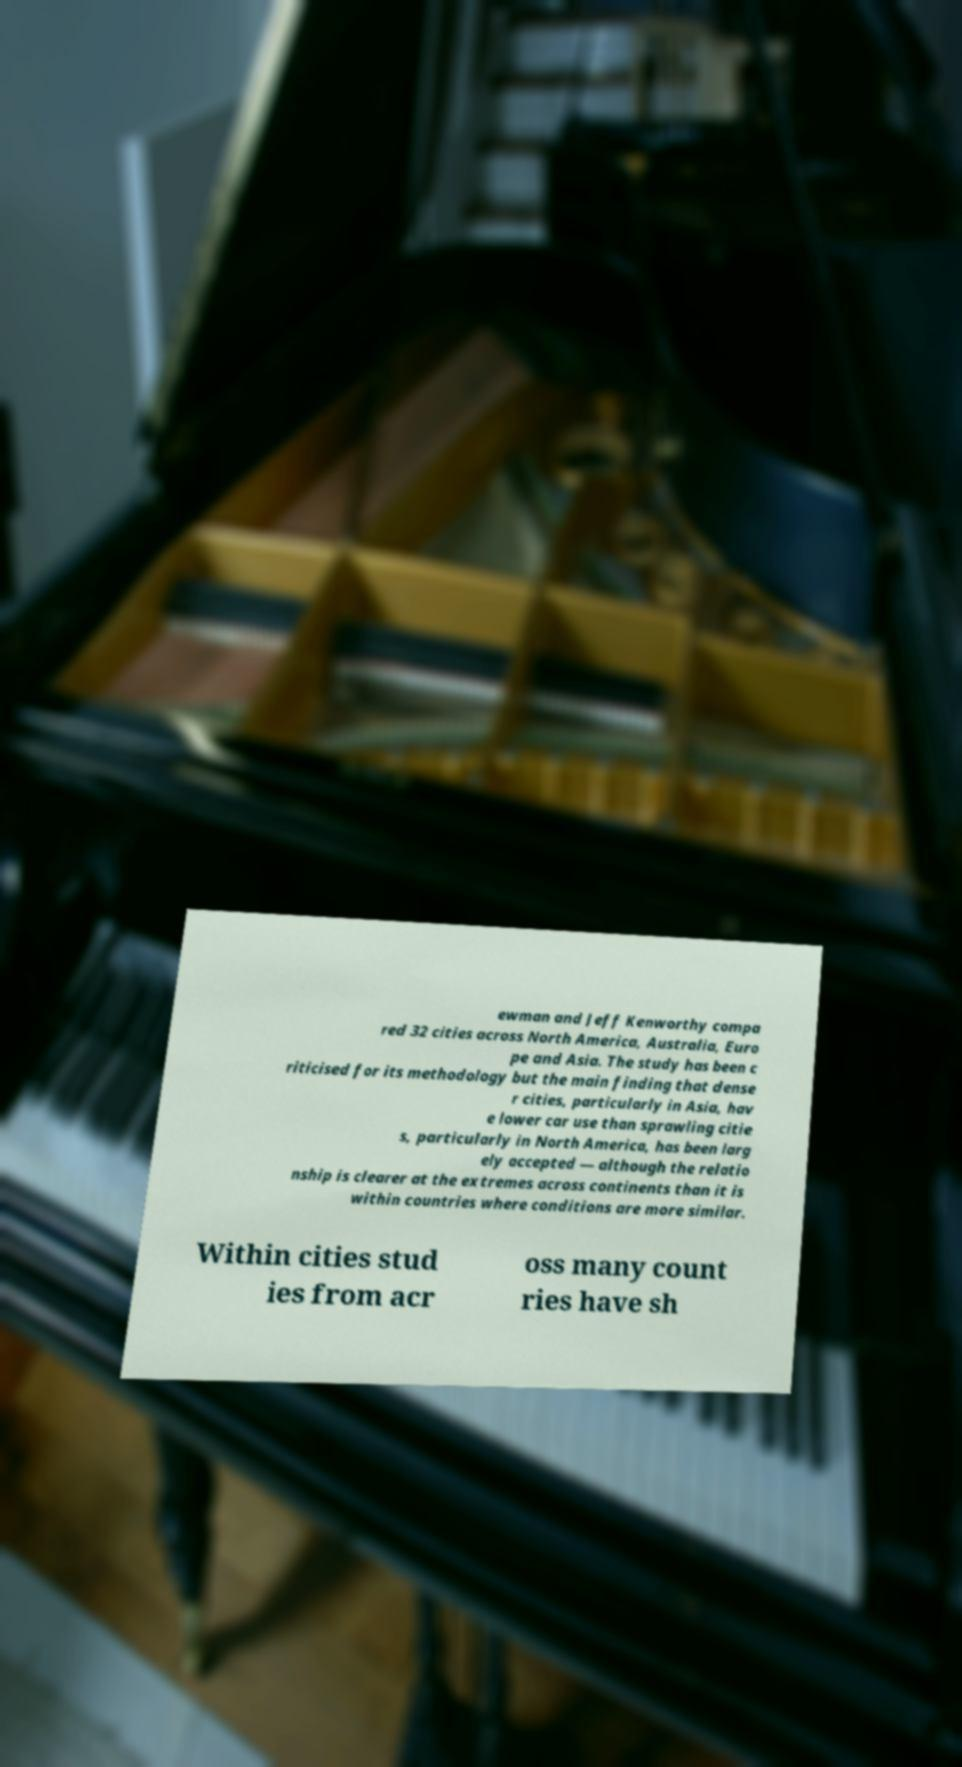Please identify and transcribe the text found in this image. ewman and Jeff Kenworthy compa red 32 cities across North America, Australia, Euro pe and Asia. The study has been c riticised for its methodology but the main finding that dense r cities, particularly in Asia, hav e lower car use than sprawling citie s, particularly in North America, has been larg ely accepted — although the relatio nship is clearer at the extremes across continents than it is within countries where conditions are more similar. Within cities stud ies from acr oss many count ries have sh 